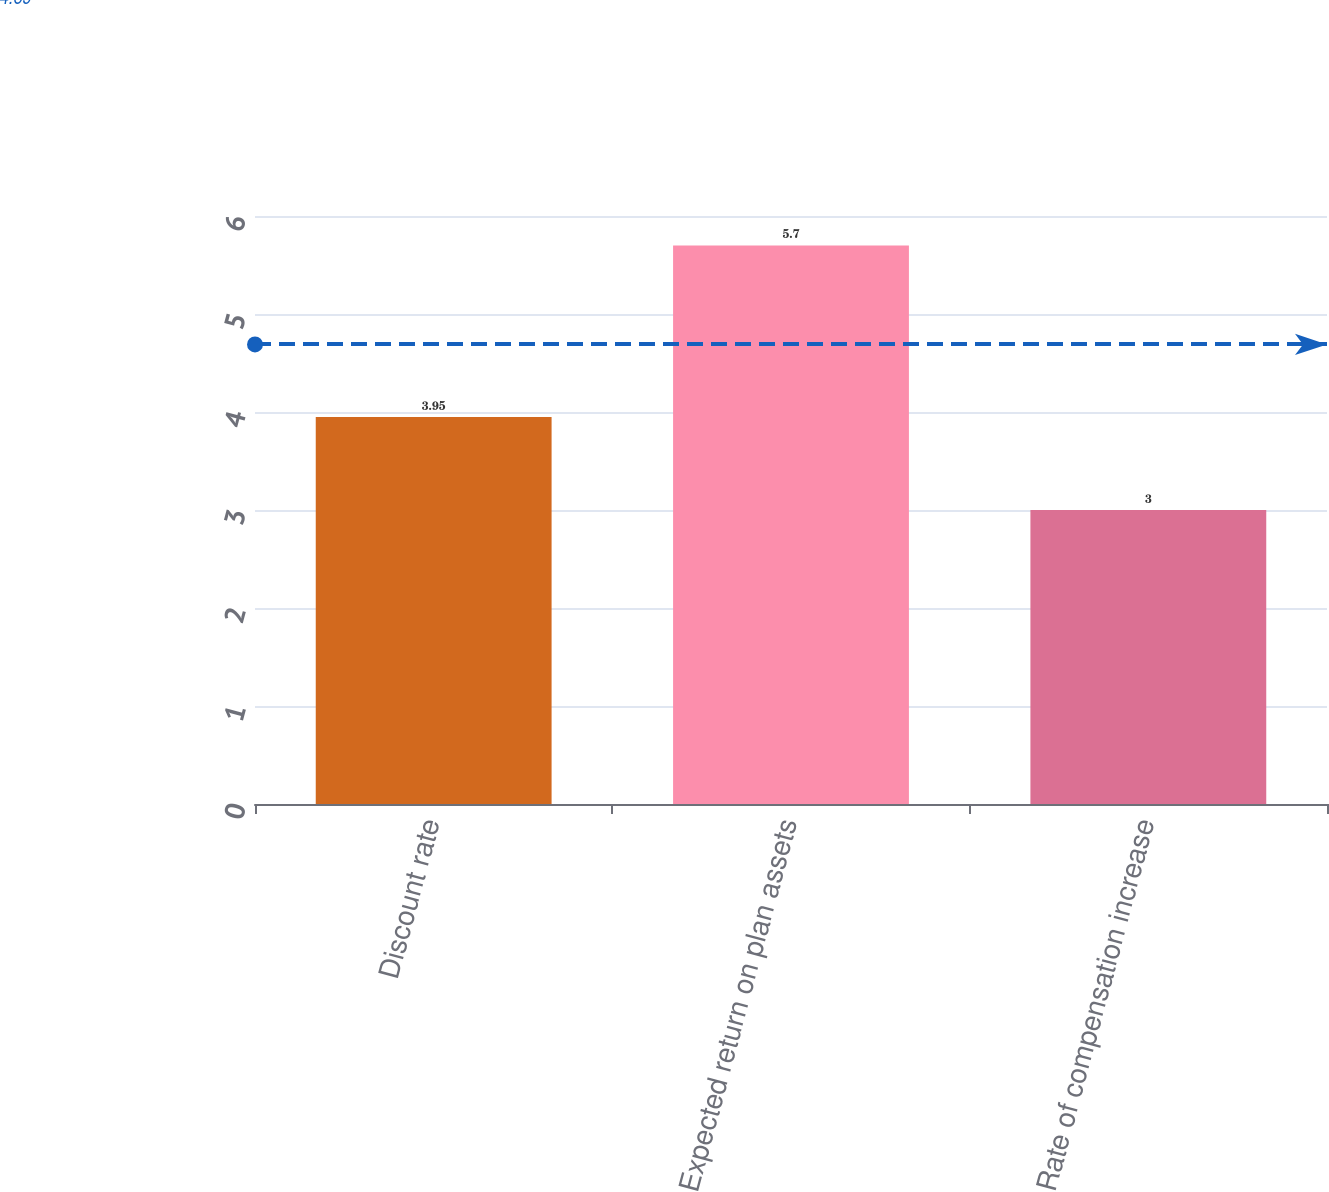Convert chart. <chart><loc_0><loc_0><loc_500><loc_500><bar_chart><fcel>Discount rate<fcel>Expected return on plan assets<fcel>Rate of compensation increase<nl><fcel>3.95<fcel>5.7<fcel>3<nl></chart> 